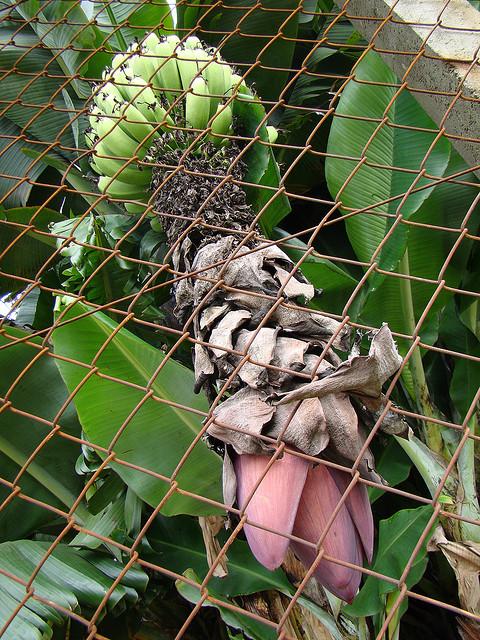What is the fruit shown?
Quick response, please. Banana. Is there a fence in the picture?
Give a very brief answer. Yes. Is this a tropical setting?
Answer briefly. Yes. 